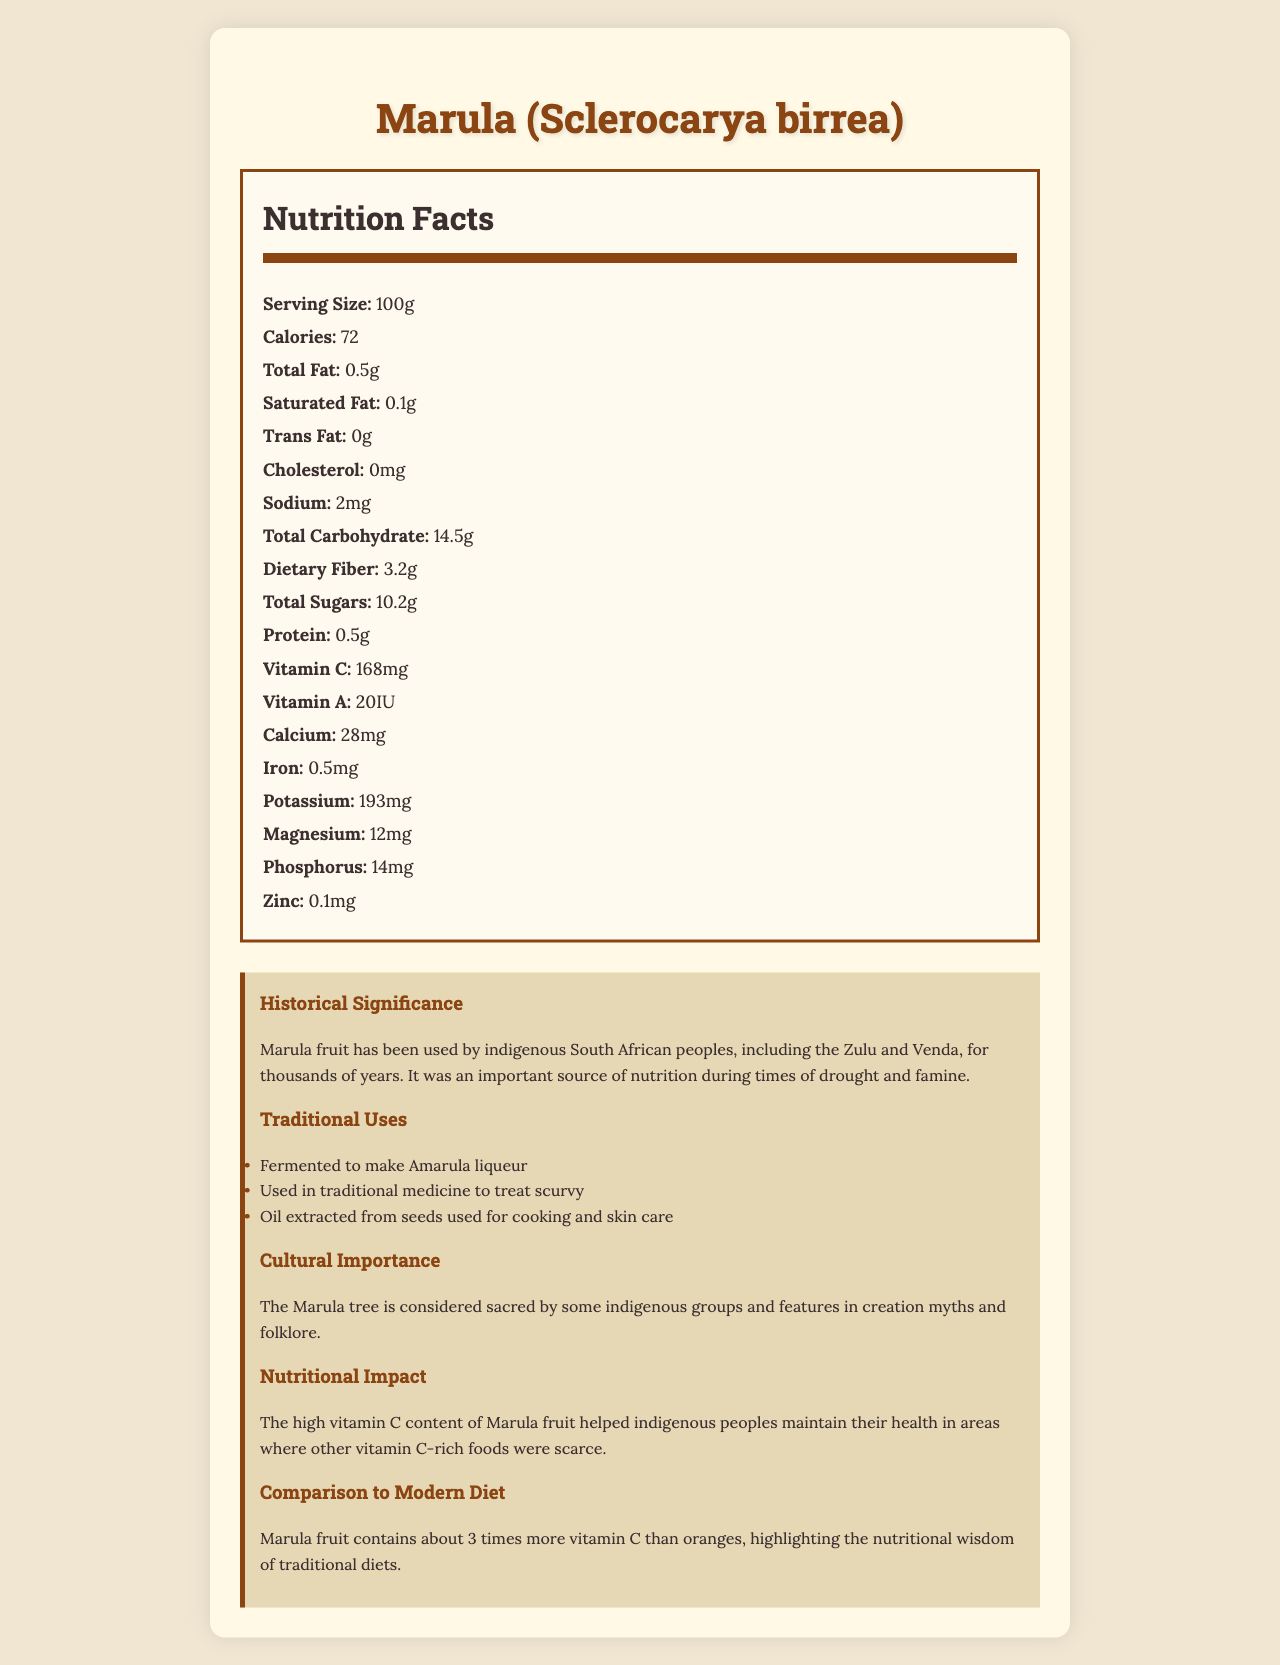what is the serving size of Marula fruit? The document states that the serving size of Marula fruit is 100g.
Answer: 100g how many calories does Marula fruit contain per serving? According to the document, Marula fruit contains 72 calories per 100g serving.
Answer: 72 which vitamin is present in the highest amount in Marula fruit? The document mentions that Marula fruit contains 168 mg of Vitamin C, which is the highest amount among the listed vitamins and minerals.
Answer: Vitamin C how does Marula fruit help maintain health in traditional diets? The document explains that the high Vitamin C content of Marula fruit helped indigenous peoples maintain their health where other vitamin C-rich foods were scarce.
Answer: High Vitamin C content who are some of the indigenous peoples that used Marula fruit? The document states that the Zulu and Venda peoples have used Marula fruit for thousands of years.
Answer: Zulu and Venda compare the Vitamin C content of Marula fruit to that of oranges. A. Marula fruit has less Vitamin C than oranges B. Marula fruit has about the same amount of Vitamin C as oranges C. Marula fruit has about 3 times more Vitamin C than oranges The document compares Marula fruit to modern diets, highlighting that Marula fruit contains about 3 times more Vitamin C than oranges.
Answer: C which of the following traditional uses is NOT mentioned for Marula fruit? A. Fermentation to make liqueur B. Cooking with seed oil C. Using leaves for tea D. Treating scurvy The traditional uses listed for Marula fruit are fermentation to make liqueur, cooking with seed oil, and treating scurvy, but not using leaves for tea.
Answer: C is the Marula fruit considered sacred by some indigenous groups? The document mentions that the Marula tree is considered sacred by some indigenous groups and is featured in creation myths and folklore.
Answer: Yes describe the overall nutritional benefits and cultural significance of Marula fruit as depicted in the document. The document covers various aspects of Marula fruit, including detailed nutritional information, historical significance, traditional uses, and cultural importance. It underscores the fruit's high Vitamin C content and how it was integrated into traditional diets and practices.
Answer: Marula fruit is highly nutritious, particularly rich in Vitamin C, which helped sustain indigenous peoples' health where vitamin C-rich foods were scarce. Traditionally, it was used to make Amarula liqueur, treat scurvy, and extract oil for cooking and skincare. Culturally, the Marula tree is sacred and features heavily in local mythology. The document illustrates the fruit's importance both nutritionally and culturally. how many grams of dietary fiber are in a 100g serving of Marula fruit? The document lists that a 100g serving of Marula fruit contains 3.2g of dietary fiber.
Answer: 3.2g when was the Marula tree first domesticated? The document does not provide information on when the Marula tree was first domesticated.
Answer: Cannot be determined 